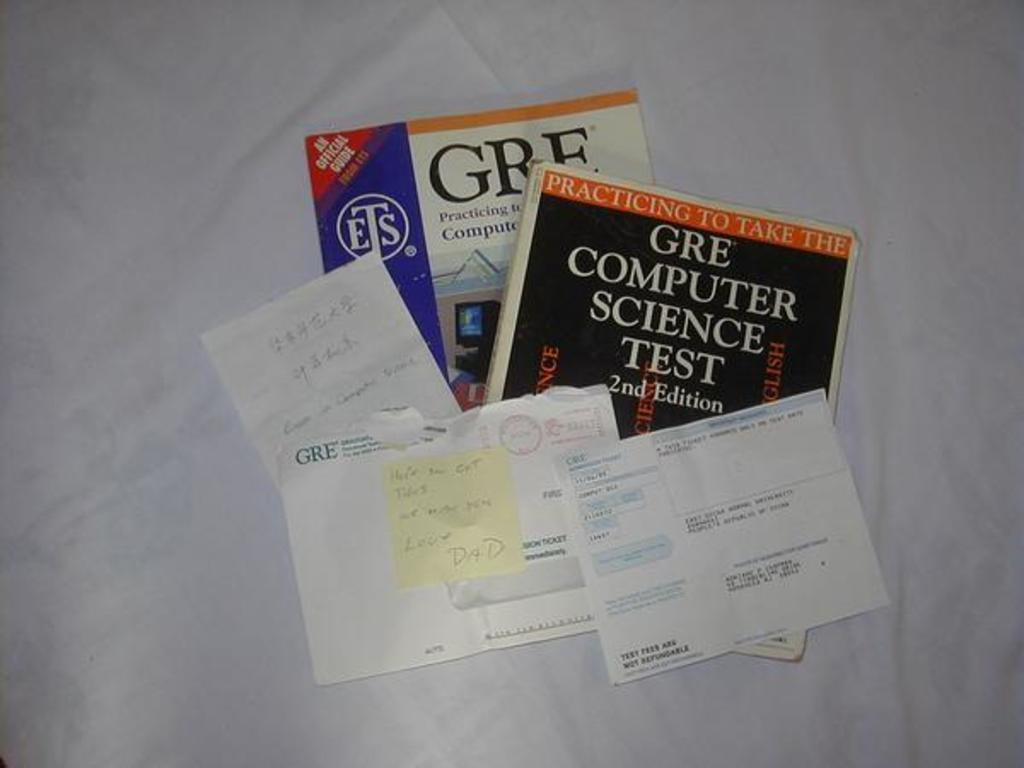Provide a one-sentence caption for the provided image. Several sheets of paperwork lie atop two GRE test prep books. 